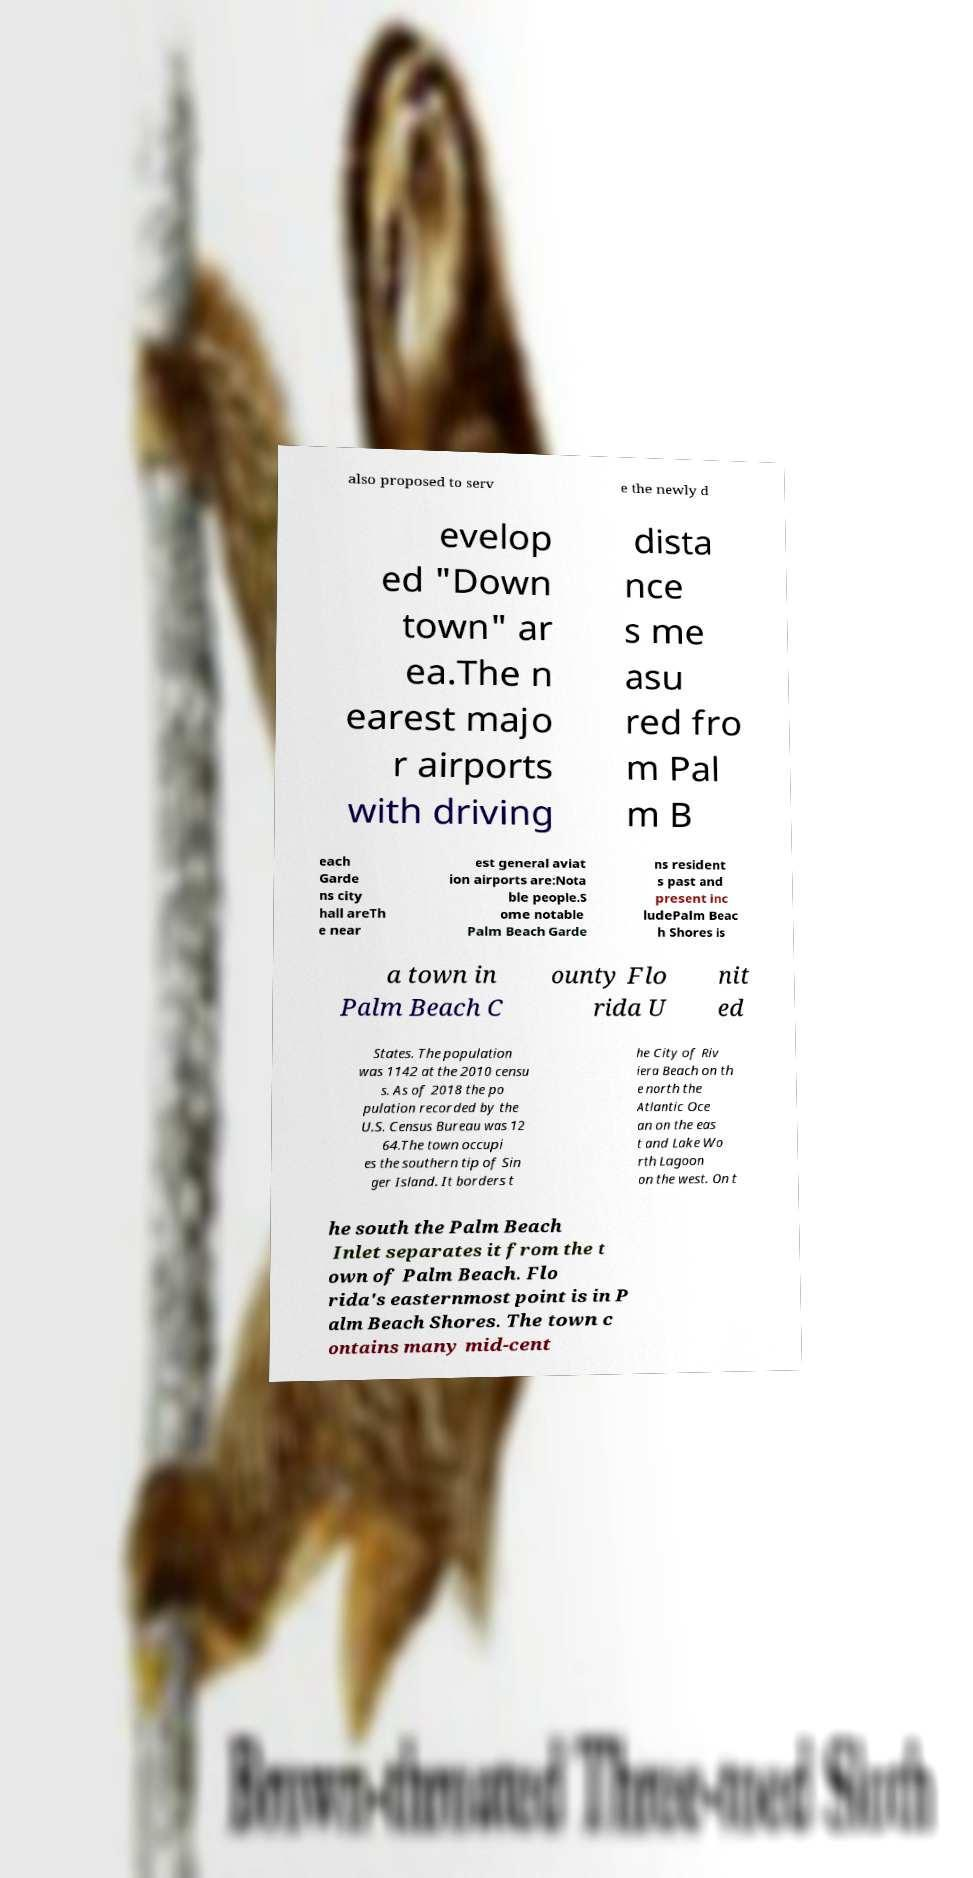What messages or text are displayed in this image? I need them in a readable, typed format. also proposed to serv e the newly d evelop ed "Down town" ar ea.The n earest majo r airports with driving dista nce s me asu red fro m Pal m B each Garde ns city hall areTh e near est general aviat ion airports are:Nota ble people.S ome notable Palm Beach Garde ns resident s past and present inc ludePalm Beac h Shores is a town in Palm Beach C ounty Flo rida U nit ed States. The population was 1142 at the 2010 censu s. As of 2018 the po pulation recorded by the U.S. Census Bureau was 12 64.The town occupi es the southern tip of Sin ger Island. It borders t he City of Riv iera Beach on th e north the Atlantic Oce an on the eas t and Lake Wo rth Lagoon on the west. On t he south the Palm Beach Inlet separates it from the t own of Palm Beach. Flo rida's easternmost point is in P alm Beach Shores. The town c ontains many mid-cent 